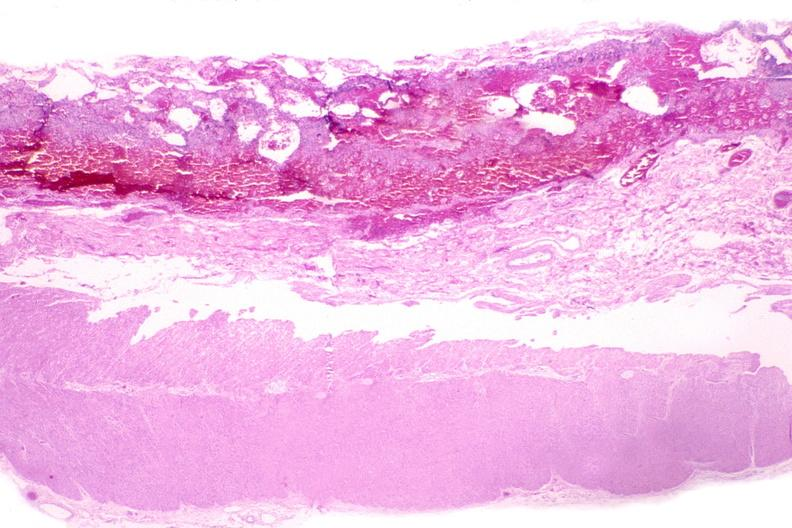s gastrointestinal present?
Answer the question using a single word or phrase. Yes 